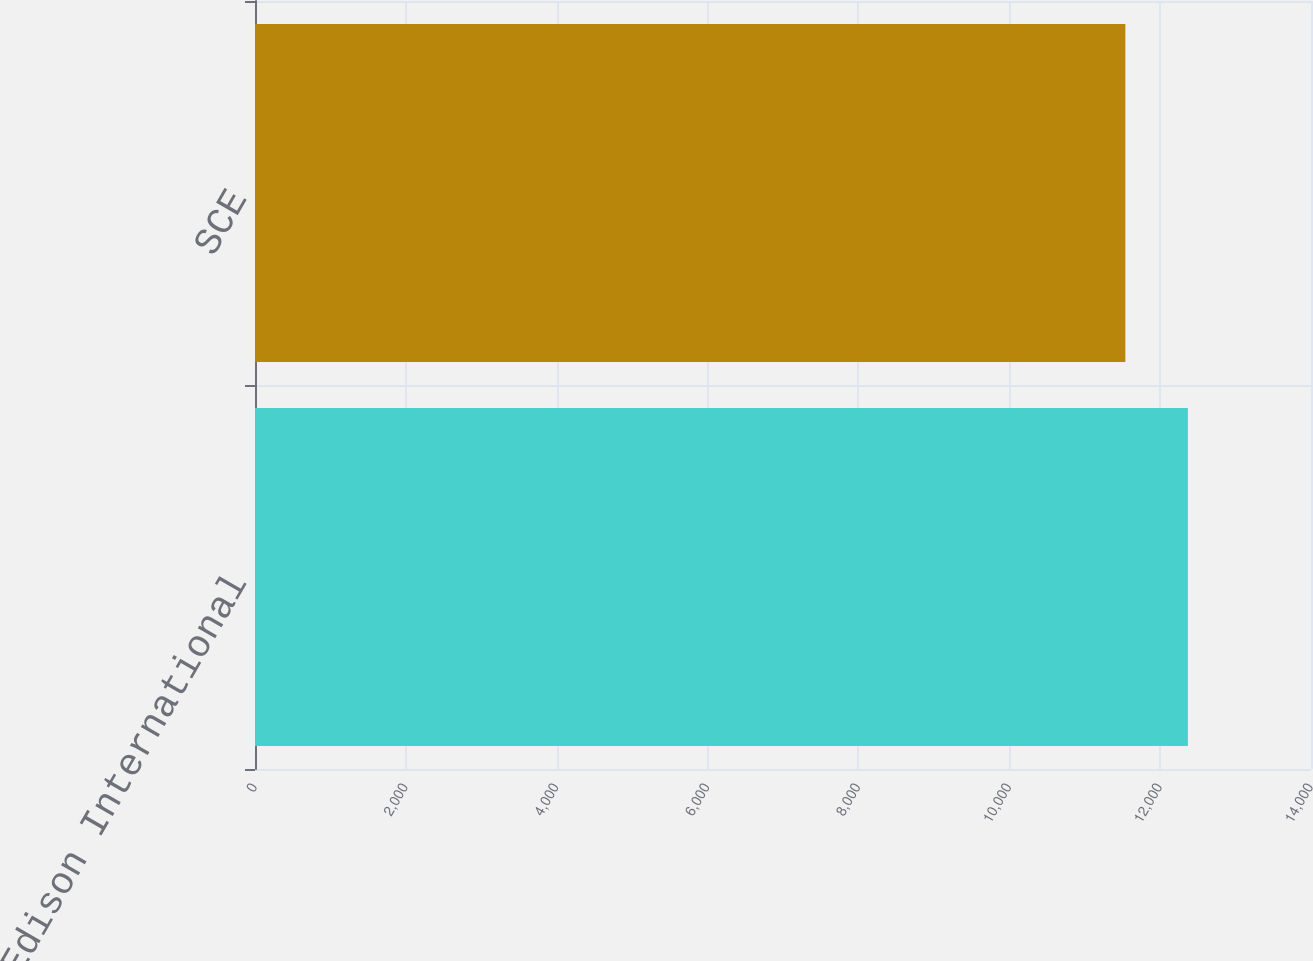<chart> <loc_0><loc_0><loc_500><loc_500><bar_chart><fcel>Edison International<fcel>SCE<nl><fcel>12368<fcel>11539<nl></chart> 